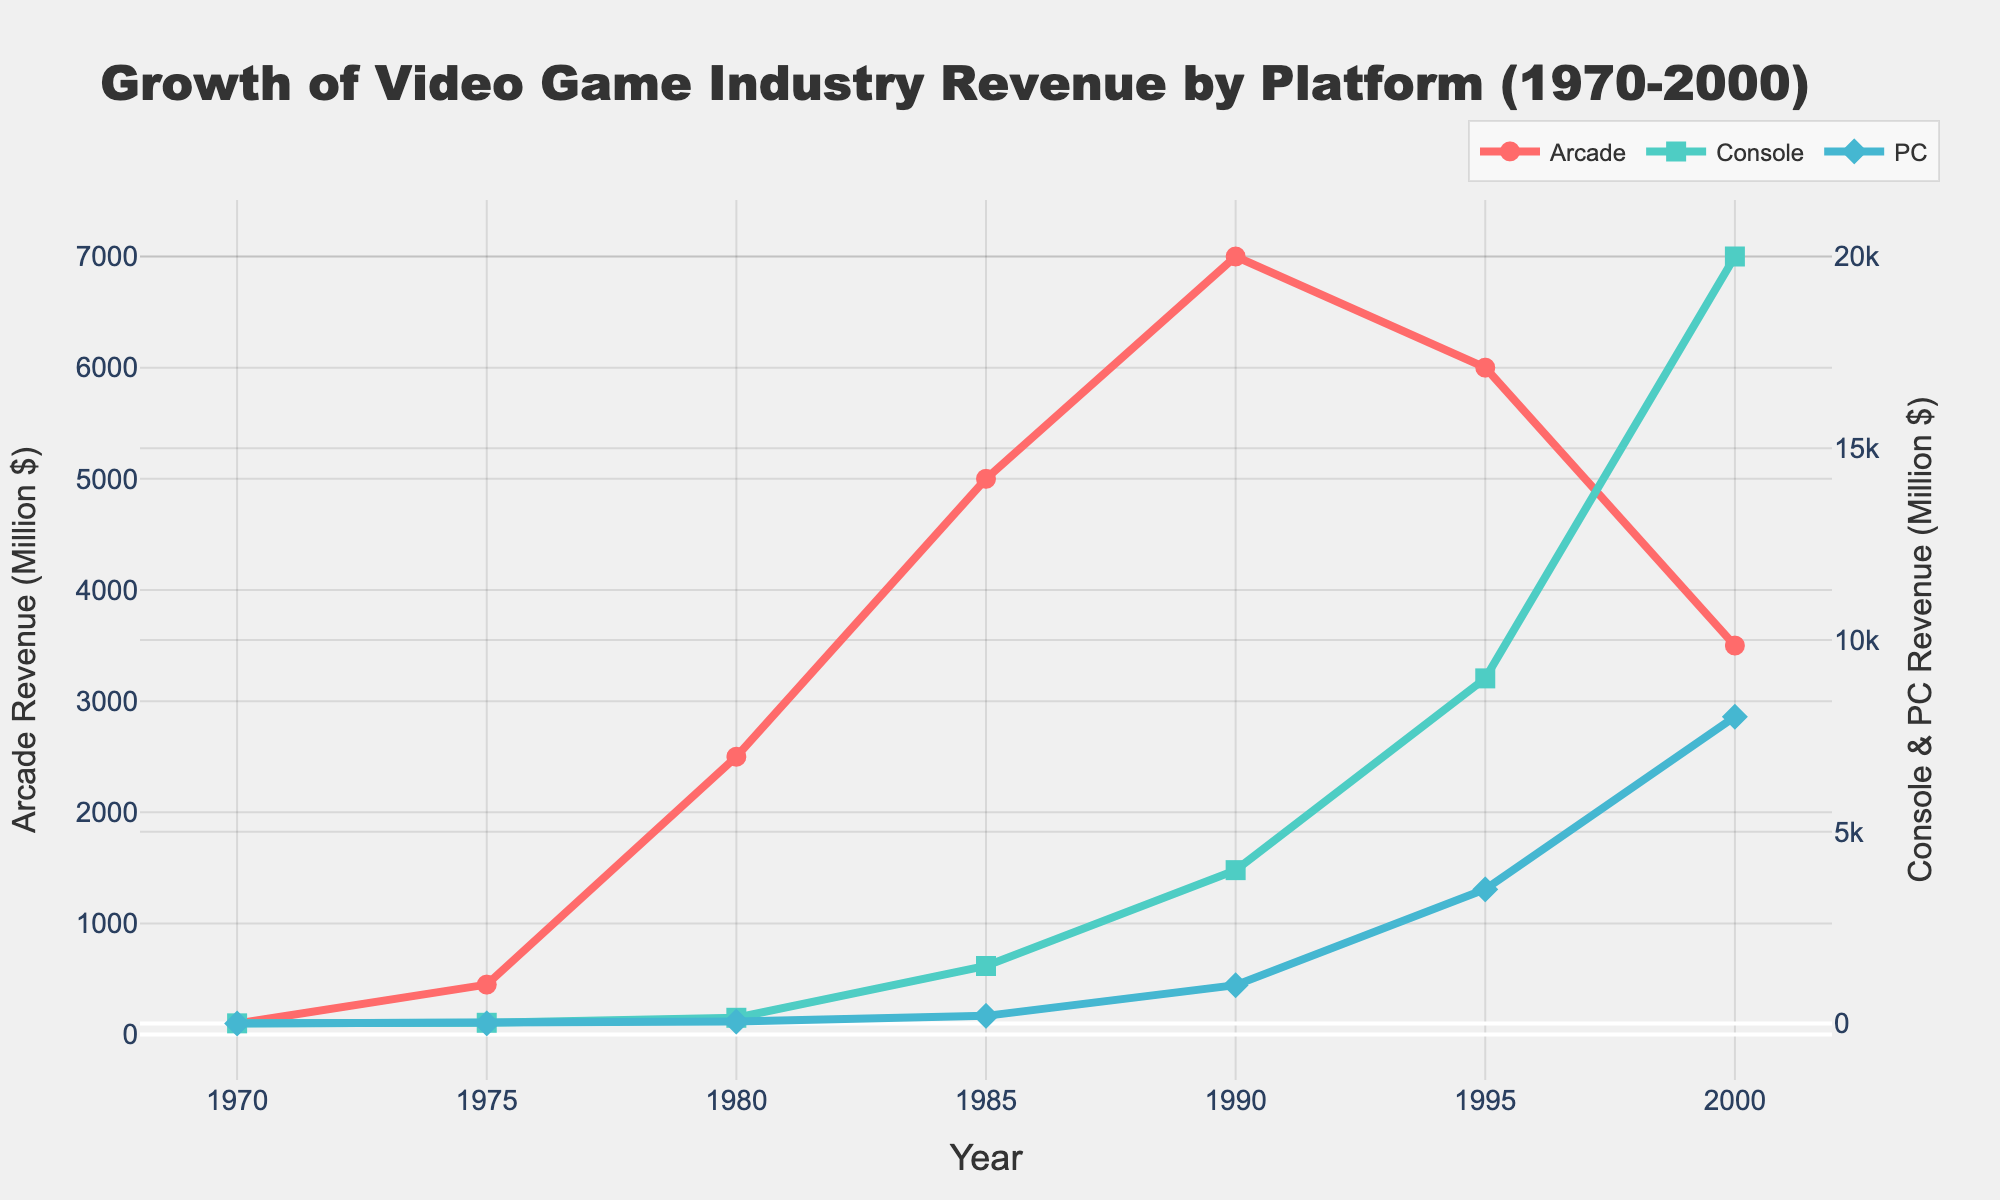what is the revenue difference between Arcade and Console gaming in 1975? The revenue for Arcade in 1975 is 450 million dollars and for Console is 20 million dollars. The difference is 450 - 20 = 430 million dollars.
Answer: 430 million dollars During which year did Console gaming revenue surpass Arcade gaming revenue? By examining the figure, Console gaming revenue first surpasses Arcade gaming revenue in 1995, where Console revenue is about 9000 million dollars whereas Arcade revenue is about 6000 million dollars.
Answer: 1995 What's the combined revenue of Arcade and PC gaming in 1985? The revenue for Arcade gaming in 1985 is 5000 million dollars, and for PC gaming, it is 200 million dollars. The combined revenue is 5000 + 200 = 5200 million dollars.
Answer: 5200 million dollars Which platform had the highest growth rate between 1980 and 1990? From the chart, Arcade gaming revenue increased from 2500 to 7000 million dollars, Console from 150 to 4000 million dollars, and PC gaming from 50 to 1000 million dollars. To find the growth, (new value - old value)/old value: Arcade: (7000-2500)/2500 = 1.8; Console: (4000-150)/150 = 25.67; PC: (1000-50)/50 = 19. The highest growth rate is for Console.
Answer: Console In which year did PC gaming revenue first reach 1000 million dollars? From the graph, PC gaming revenue first reached 1000 million dollars in 1990.
Answer: 1990 What's the average revenue of PC gaming from 1980 to 2000? The revenues for PC gaming from 1980 to 2000 are 50, 200, 1000, 3500, and 8000. The sum is 50 + 200 + 1000 + 3500 + 8000 = 12750. The number of data points is 5. So, the average is 12750/5 = 2550 million dollars.
Answer: 2550 million dollars Which platform had the steepest decline in revenue between 1995 and 2000? Arcade gaming declined from 6000 million dollars in 1995 to 3500 million dollars in 2000. Console and PC gaming have increasing trends for the same period. The decline in Arcade gaming is 6000 - 3500 = 2500 million dollars, which is the steepest decrease.
Answer: Arcade When did Arcade gaming achieve its maximum revenue, and what was the value? From the graph, Arcade gaming achieved its maximum revenue in 1990 where the revenue value was 7000 million dollars.
Answer: 1990, 7000 million dollars Compare the revenue trends of Console and PC gaming between 1970 and 1985? For Console gaming, the revenue increased from 5 million dollars in 1970 to 1500 million dollars in 1985. For PC gaming, it increased from 1 million dollars in 1970 to 200 million dollars in 1985. Both platforms show an increasing trend, but the growth rate for Console gaming is significantly higher than PC gaming.
Answer: Both increasing, Console had higher growth rate 